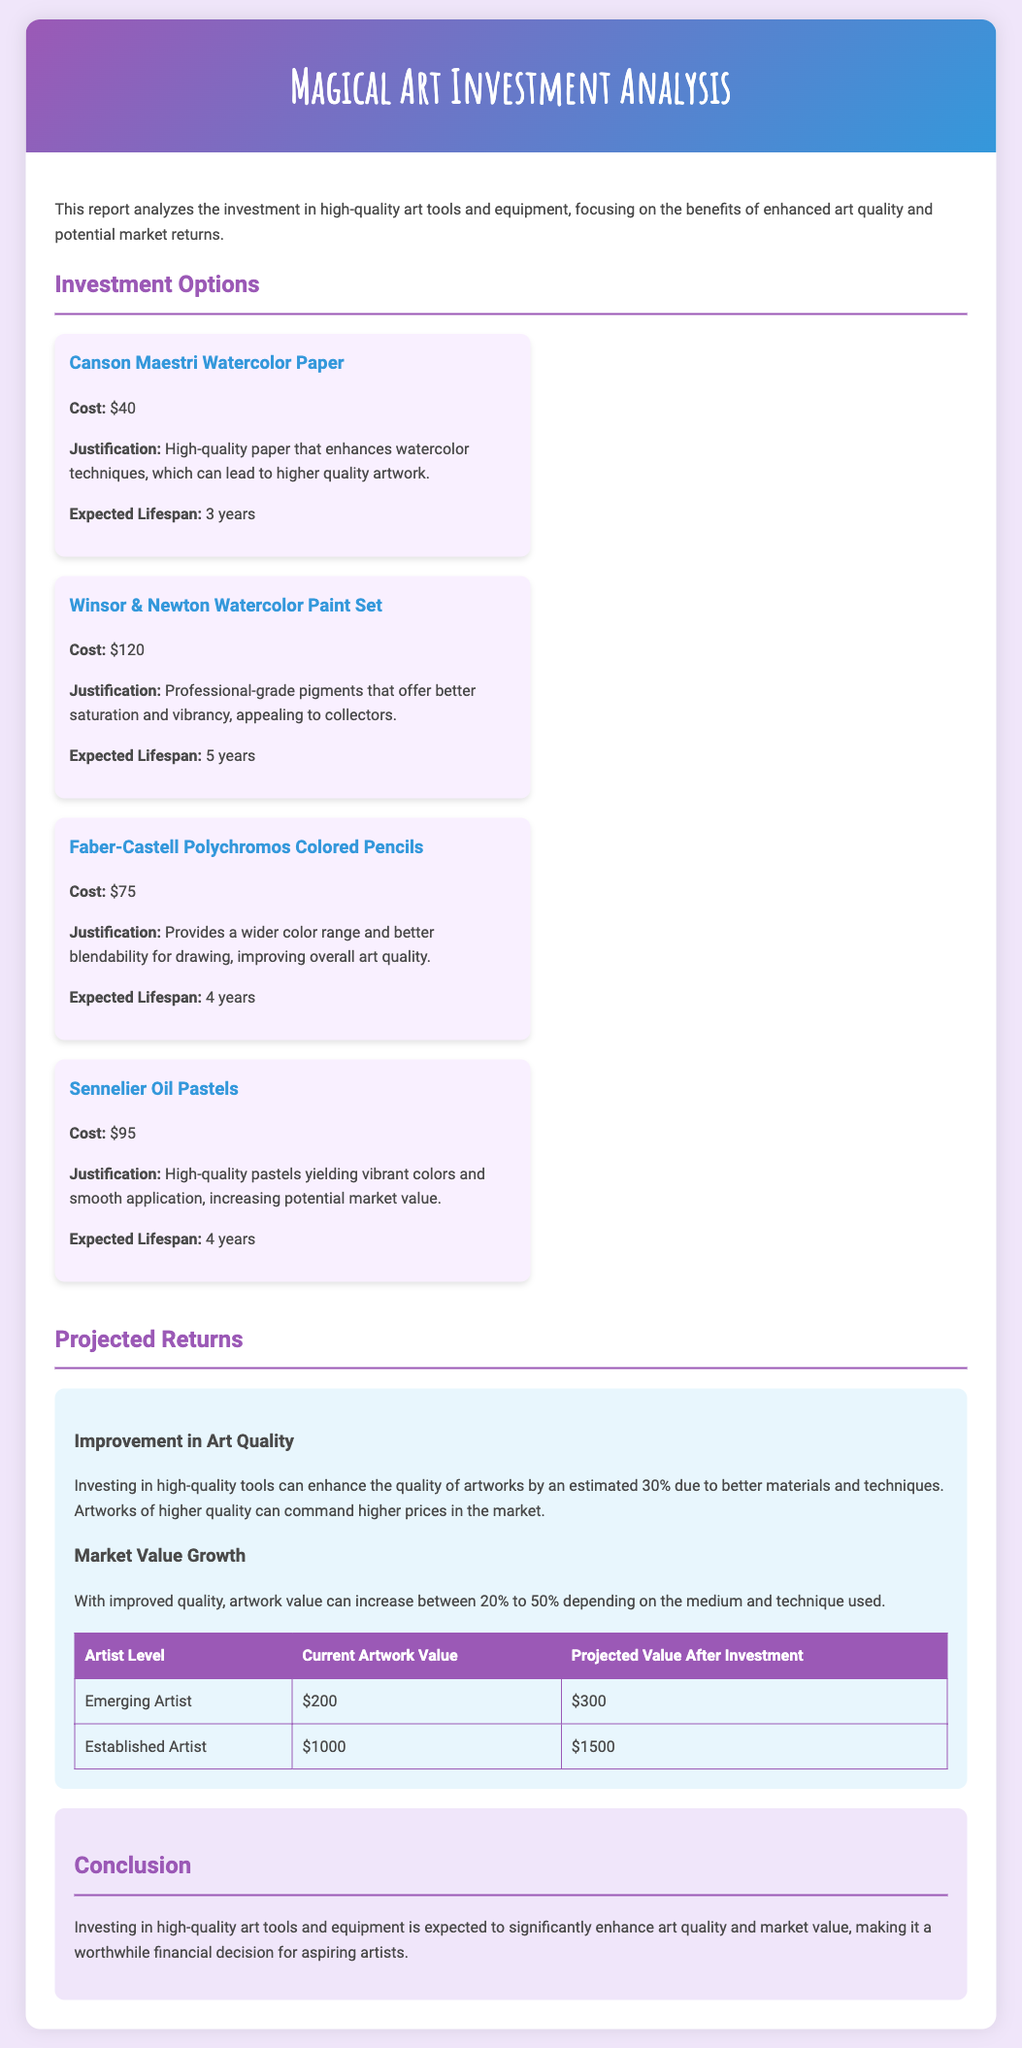What is the cost of Winsor & Newton Watercolor Paint Set? The cost is specifically mentioned in the document, which is $120.
Answer: $120 What is the projected value after investment for an established artist? This value is provided in the table as the projected increase from $1000 to $1500.
Answer: $1500 What is the expected lifespan of Canson Maestri Watercolor Paper? The document states that the expected lifespan is 3 years.
Answer: 3 years By what percentage can artwork quality improve with the investment in tools? The estimated improvement in art quality is mentioned as 30%.
Answer: 30% What justified the investment in Faber-Castell Polychromos Colored Pencils? It mentions that these pencils provide a wider color range and better blendability for drawing.
Answer: Wider color range and better blendability How much can the market value of artwork increase? The document states that it can increase between 20% to 50%.
Answer: 20% to 50% What is the cost of Sennelier Oil Pastels? The document lists the cost of these pastels specifically as $95.
Answer: $95 What is the current artwork value for an emerging artist? The current value for an emerging artist is detailed in the table as $200.
Answer: $200 What is the conclusion regarding the investment in art tools? The conclusion emphasizes that investing in high-quality tools is a worthwhile financial decision for aspiring artists.
Answer: Worthwhile financial decision 